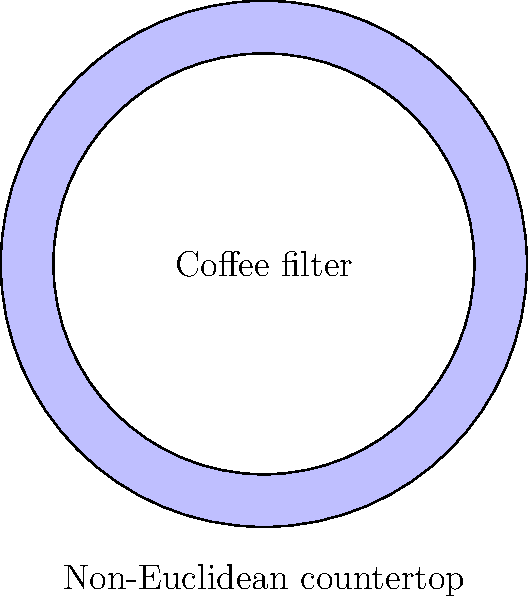A circular coffee filter with a radius of 5 cm is placed on a non-Euclidean countertop at your specialty coffee shop. The curvature of the countertop causes the filter to have an effective area that is 15% larger than it would on a flat surface. What is the effective area of the coffee filter on this non-Euclidean surface? Let's approach this step-by-step:

1) First, let's calculate the area of the coffee filter on a flat (Euclidean) surface:
   $A = \pi r^2$
   $A = \pi (5 \text{ cm})^2 = 25\pi \text{ cm}^2$

2) Now, we're told that the effective area on the non-Euclidean surface is 15% larger. This means we need to multiply the Euclidean area by 1.15:

   $A_{non-Euclidean} = 25\pi \text{ cm}^2 \times 1.15$

3) Let's calculate this:
   $A_{non-Euclidean} = 28.75\pi \text{ cm}^2$

4) If we want to express this in terms of square centimeters without π:
   $A_{non-Euclidean} = 28.75\pi \text{ cm}^2 \approx 90.32 \text{ cm}^2$

Therefore, the effective area of the coffee filter on the non-Euclidean countertop is approximately 90.32 cm².
Answer: $90.32 \text{ cm}^2$ 